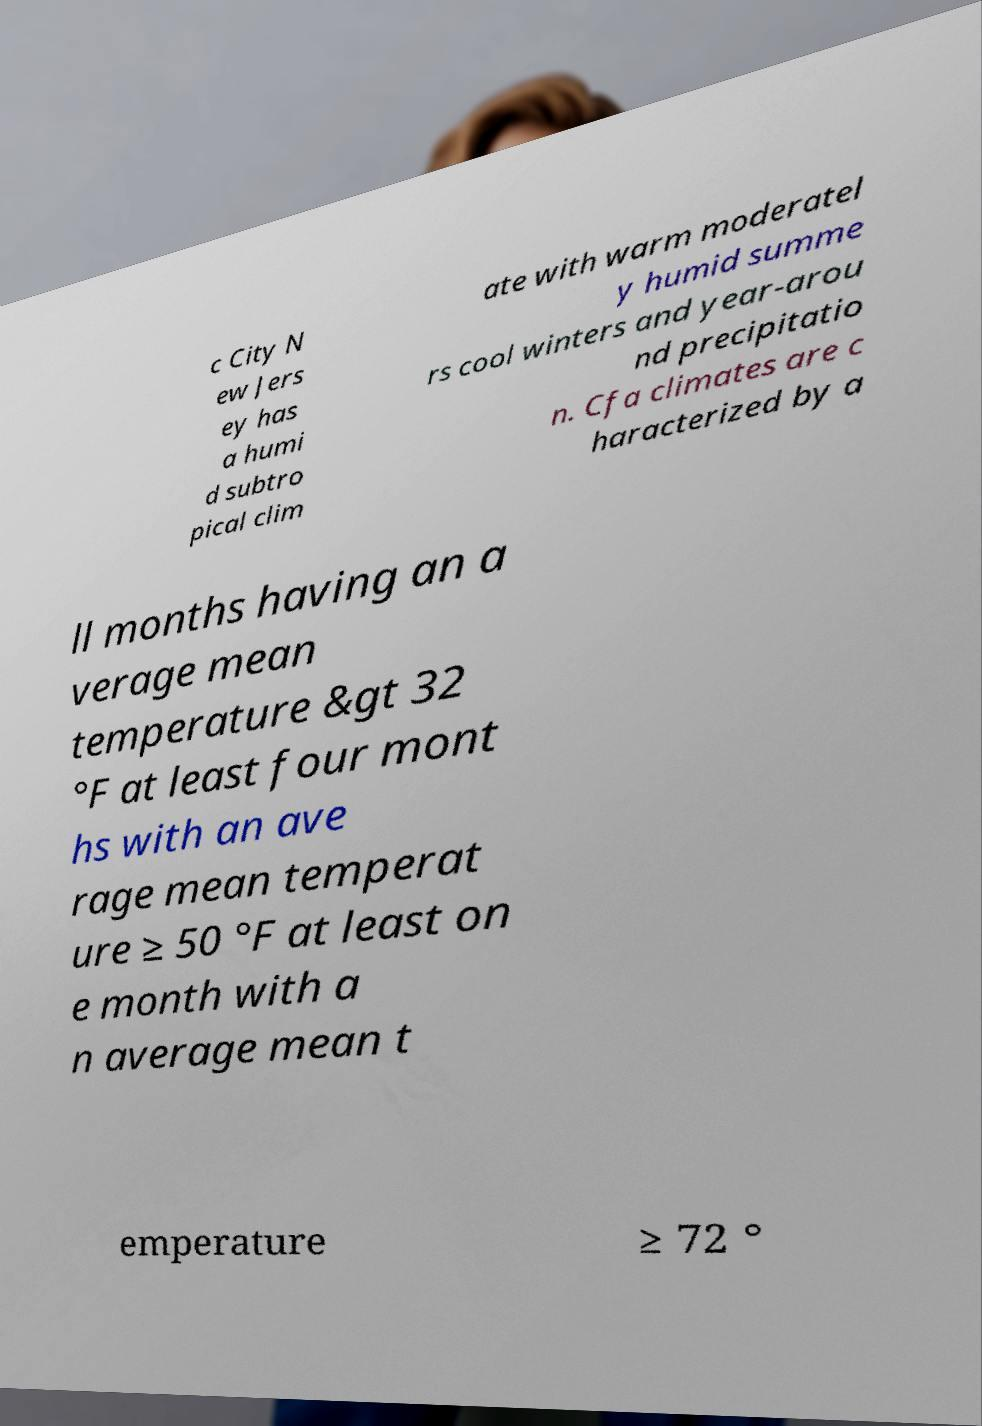Could you assist in decoding the text presented in this image and type it out clearly? c City N ew Jers ey has a humi d subtro pical clim ate with warm moderatel y humid summe rs cool winters and year-arou nd precipitatio n. Cfa climates are c haracterized by a ll months having an a verage mean temperature &gt 32 °F at least four mont hs with an ave rage mean temperat ure ≥ 50 °F at least on e month with a n average mean t emperature ≥ 72 ° 